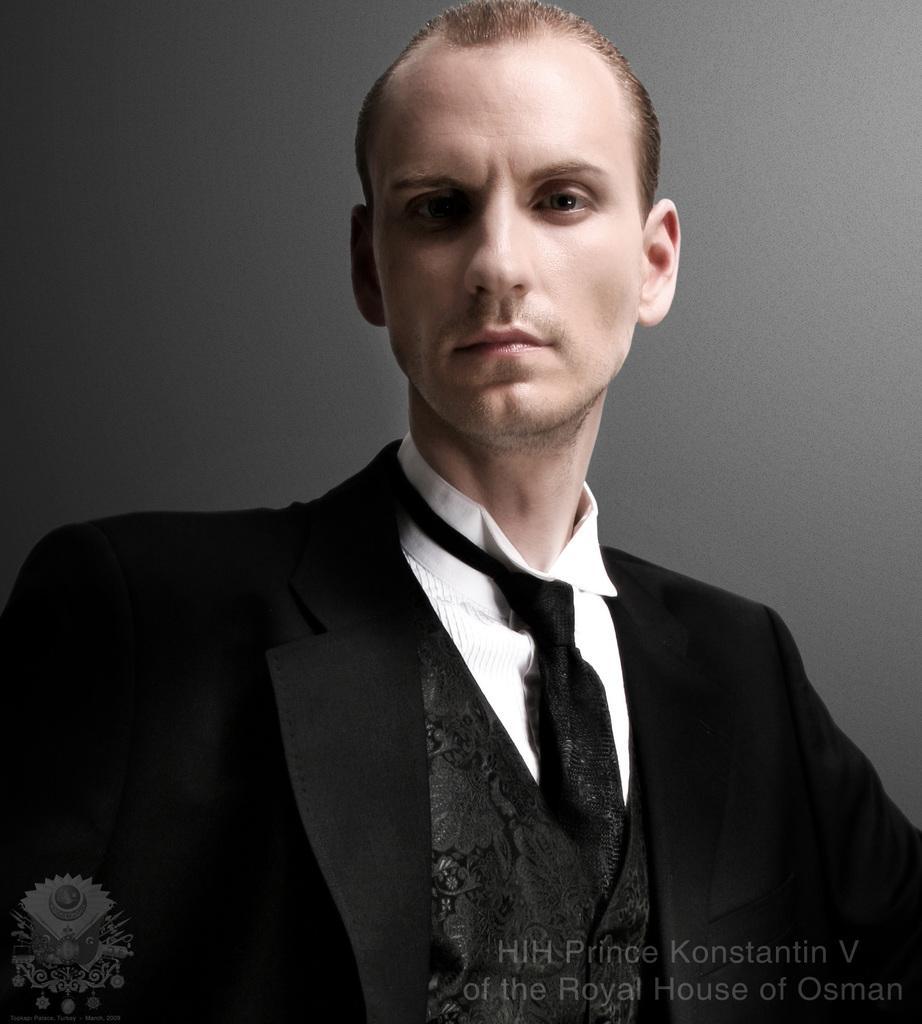Could you give a brief overview of what you see in this image? In this image I can see a person wearing black and white colored dress. I can see the grey colored background. 